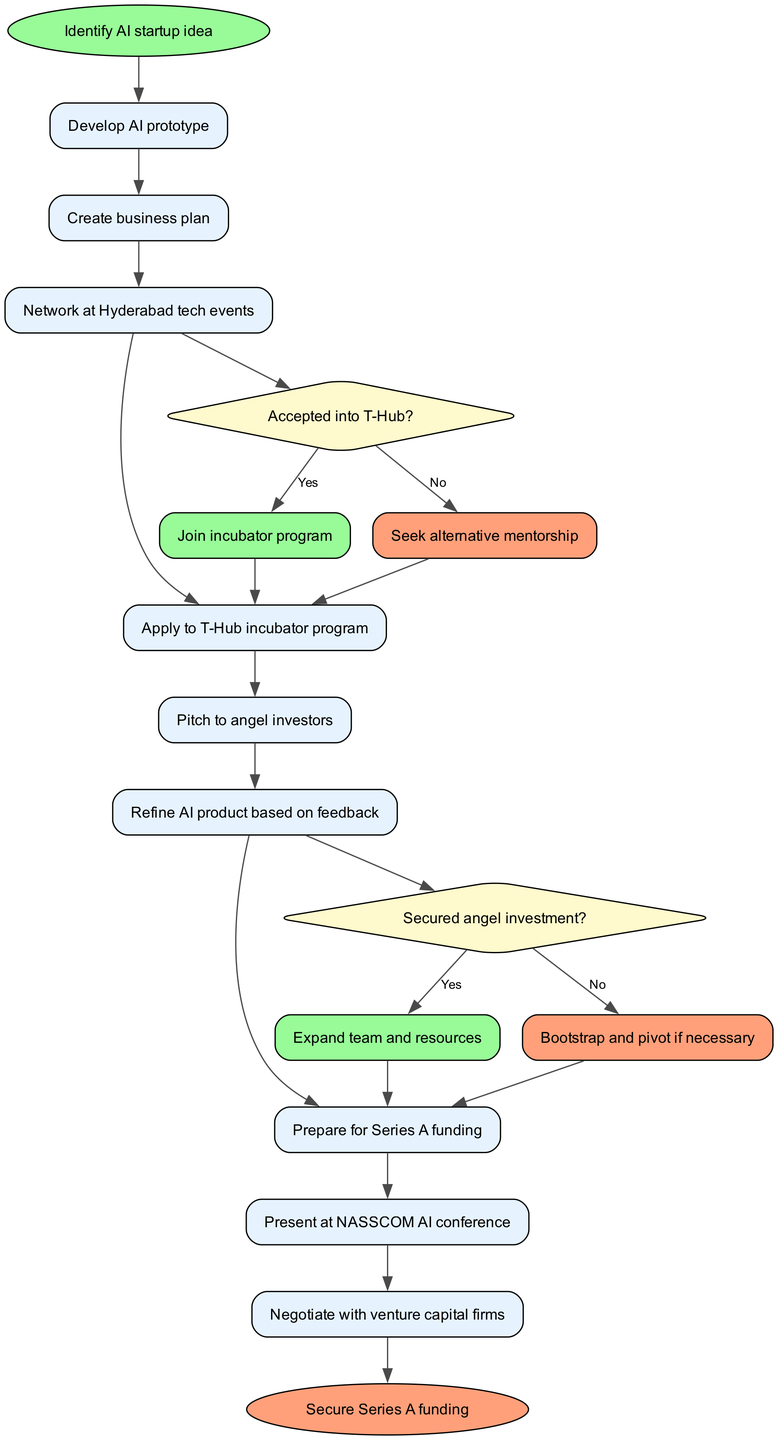What is the first activity in the process? The diagram starts with the "Identify AI startup idea" node, which is represented as the first activity in the flow.
Answer: Identify AI startup idea How many decision nodes are present in the diagram? The diagram includes two decision nodes, which are related to acceptance into the T-Hub program and securing angel investment.
Answer: 2 What action follows "Pitch to angel investors" if the angel investment is not secured? The flow indicates that if the angel investment is not secured, the next action is "Bootstrap and pivot if necessary," based on the decision node's "No" outcome.
Answer: Bootstrap and pivot if necessary What is the end result of the process depicted in the diagram? The diagram finishes at the "Secure Series A funding" node, which is the final outcome of the activities.
Answer: Secure Series A funding If the startup is accepted into the T-Hub incubator, what is the next step? According to the decision node regarding T-Hub acceptance, if accepted, the next step is to "Join incubator program."
Answer: Join incubator program What is the last activity before securing Series A funding? The diagram indicates that "Prepare for Series A funding" is the last activity before reaching the final node for securing funds.
Answer: Prepare for Series A funding What happens after "Expand team and resources"? Following "Expand team and resources," the process progresses to "Prepare for Series A funding," as specified in the flow from securing angel investment.
Answer: Prepare for Series A funding Which activity involves networking at tech events? The activity named "Network at Hyderabad tech events" explicitly involves networking within the context of the startup process.
Answer: Network at Hyderabad tech events What is the conditional decision made after "Apply to T-Hub incubator program"? The conditional decision made is whether the startup is "Accepted into T-Hub?" which leads to two potential branches in the process.
Answer: Accepted into T-Hub? 